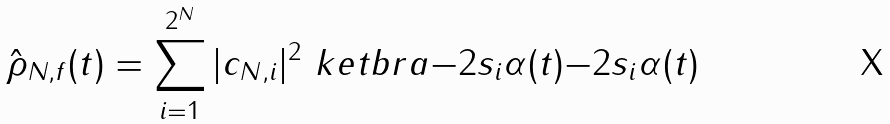<formula> <loc_0><loc_0><loc_500><loc_500>\hat { \rho } _ { N , f } ( t ) = \sum _ { i = 1 } ^ { 2 ^ { N } } | c _ { N , i } | ^ { 2 } \ k e t b r a { - 2 s _ { i } \alpha ( t ) } { - 2 s _ { i } \alpha ( t ) }</formula> 